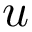<formula> <loc_0><loc_0><loc_500><loc_500>u</formula> 